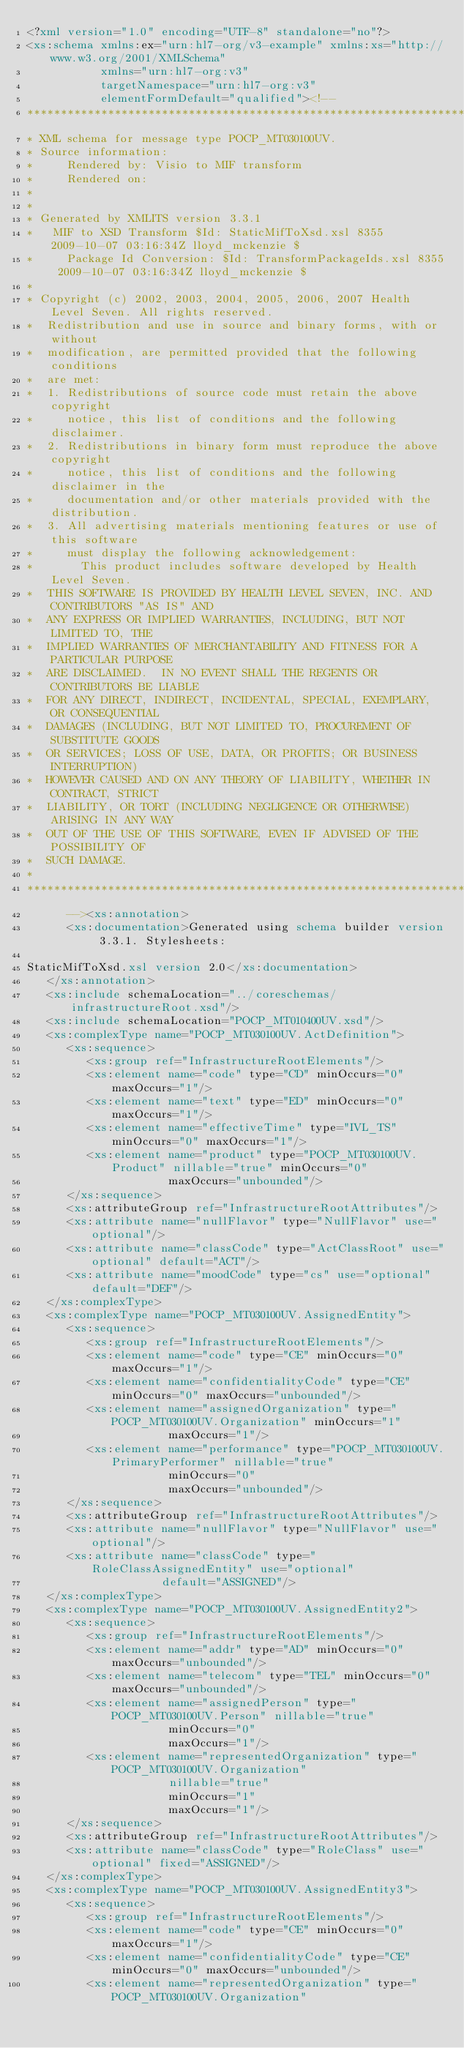Convert code to text. <code><loc_0><loc_0><loc_500><loc_500><_XML_><?xml version="1.0" encoding="UTF-8" standalone="no"?>
<xs:schema xmlns:ex="urn:hl7-org/v3-example" xmlns:xs="http://www.w3.org/2001/XMLSchema"
           xmlns="urn:hl7-org:v3"
           targetNamespace="urn:hl7-org:v3"
           elementFormDefault="qualified"><!--
*****************************************************************************************************************
* XML schema for message type POCP_MT030100UV.
* Source information:
*     Rendered by: Visio to MIF transform
*     Rendered on: 
* 
*
* Generated by XMLITS version 3.3.1
*   MIF to XSD Transform $Id: StaticMifToXsd.xsl 8355 2009-10-07 03:16:34Z lloyd_mckenzie $
*     Package Id Conversion: $Id: TransformPackageIds.xsl 8355 2009-10-07 03:16:34Z lloyd_mckenzie $
*
* Copyright (c) 2002, 2003, 2004, 2005, 2006, 2007 Health Level Seven. All rights reserved.
*  Redistribution and use in source and binary forms, with or without
*  modification, are permitted provided that the following conditions
*  are met:
*  1. Redistributions of source code must retain the above copyright
*     notice, this list of conditions and the following disclaimer.
*  2. Redistributions in binary form must reproduce the above copyright
*     notice, this list of conditions and the following disclaimer in the
*     documentation and/or other materials provided with the distribution.
*  3. All advertising materials mentioning features or use of this software
*     must display the following acknowledgement:
*       This product includes software developed by Health Level Seven.
*  THIS SOFTWARE IS PROVIDED BY HEALTH LEVEL SEVEN, INC. AND CONTRIBUTORS "AS IS" AND
*  ANY EXPRESS OR IMPLIED WARRANTIES, INCLUDING, BUT NOT LIMITED TO, THE
*  IMPLIED WARRANTIES OF MERCHANTABILITY AND FITNESS FOR A PARTICULAR PURPOSE
*  ARE DISCLAIMED.  IN NO EVENT SHALL THE REGENTS OR CONTRIBUTORS BE LIABLE
*  FOR ANY DIRECT, INDIRECT, INCIDENTAL, SPECIAL, EXEMPLARY, OR CONSEQUENTIAL
*  DAMAGES (INCLUDING, BUT NOT LIMITED TO, PROCUREMENT OF SUBSTITUTE GOODS
*  OR SERVICES; LOSS OF USE, DATA, OR PROFITS; OR BUSINESS INTERRUPTION)
*  HOWEVER CAUSED AND ON ANY THEORY OF LIABILITY, WHETHER IN CONTRACT, STRICT
*  LIABILITY, OR TORT (INCLUDING NEGLIGENCE OR OTHERWISE) ARISING IN ANY WAY
*  OUT OF THE USE OF THIS SOFTWARE, EVEN IF ADVISED OF THE POSSIBILITY OF
*  SUCH DAMAGE.
*
********************************************************************************************************************
	  --><xs:annotation>
      <xs:documentation>Generated using schema builder version 3.3.1. Stylesheets:

StaticMifToXsd.xsl version 2.0</xs:documentation>
   </xs:annotation>
   <xs:include schemaLocation="../coreschemas/infrastructureRoot.xsd"/>
   <xs:include schemaLocation="POCP_MT010400UV.xsd"/>
   <xs:complexType name="POCP_MT030100UV.ActDefinition">
      <xs:sequence>
         <xs:group ref="InfrastructureRootElements"/>
         <xs:element name="code" type="CD" minOccurs="0" maxOccurs="1"/>
         <xs:element name="text" type="ED" minOccurs="0" maxOccurs="1"/>
         <xs:element name="effectiveTime" type="IVL_TS" minOccurs="0" maxOccurs="1"/>
         <xs:element name="product" type="POCP_MT030100UV.Product" nillable="true" minOccurs="0"
                     maxOccurs="unbounded"/>
      </xs:sequence>
      <xs:attributeGroup ref="InfrastructureRootAttributes"/>
      <xs:attribute name="nullFlavor" type="NullFlavor" use="optional"/>
      <xs:attribute name="classCode" type="ActClassRoot" use="optional" default="ACT"/>
      <xs:attribute name="moodCode" type="cs" use="optional" default="DEF"/>
   </xs:complexType>
   <xs:complexType name="POCP_MT030100UV.AssignedEntity">
      <xs:sequence>
         <xs:group ref="InfrastructureRootElements"/>
         <xs:element name="code" type="CE" minOccurs="0" maxOccurs="1"/>
         <xs:element name="confidentialityCode" type="CE" minOccurs="0" maxOccurs="unbounded"/>
         <xs:element name="assignedOrganization" type="POCP_MT030100UV.Organization" minOccurs="1"
                     maxOccurs="1"/>
         <xs:element name="performance" type="POCP_MT030100UV.PrimaryPerformer" nillable="true"
                     minOccurs="0"
                     maxOccurs="unbounded"/>
      </xs:sequence>
      <xs:attributeGroup ref="InfrastructureRootAttributes"/>
      <xs:attribute name="nullFlavor" type="NullFlavor" use="optional"/>
      <xs:attribute name="classCode" type="RoleClassAssignedEntity" use="optional"
                    default="ASSIGNED"/>
   </xs:complexType>
   <xs:complexType name="POCP_MT030100UV.AssignedEntity2">
      <xs:sequence>
         <xs:group ref="InfrastructureRootElements"/>
         <xs:element name="addr" type="AD" minOccurs="0" maxOccurs="unbounded"/>
         <xs:element name="telecom" type="TEL" minOccurs="0" maxOccurs="unbounded"/>
         <xs:element name="assignedPerson" type="POCP_MT030100UV.Person" nillable="true"
                     minOccurs="0"
                     maxOccurs="1"/>
         <xs:element name="representedOrganization" type="POCP_MT030100UV.Organization"
                     nillable="true"
                     minOccurs="1"
                     maxOccurs="1"/>
      </xs:sequence>
      <xs:attributeGroup ref="InfrastructureRootAttributes"/>
      <xs:attribute name="classCode" type="RoleClass" use="optional" fixed="ASSIGNED"/>
   </xs:complexType>
   <xs:complexType name="POCP_MT030100UV.AssignedEntity3">
      <xs:sequence>
         <xs:group ref="InfrastructureRootElements"/>
         <xs:element name="code" type="CE" minOccurs="0" maxOccurs="1"/>
         <xs:element name="confidentialityCode" type="CE" minOccurs="0" maxOccurs="unbounded"/>
         <xs:element name="representedOrganization" type="POCP_MT030100UV.Organization"</code> 